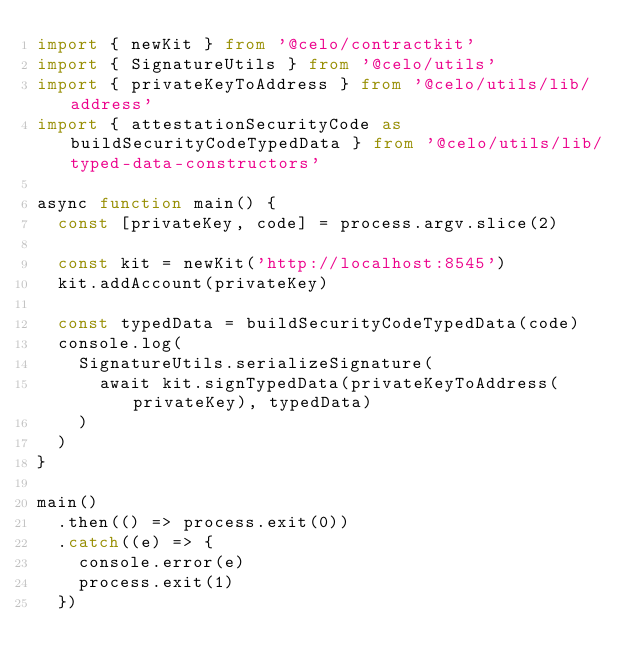Convert code to text. <code><loc_0><loc_0><loc_500><loc_500><_TypeScript_>import { newKit } from '@celo/contractkit'
import { SignatureUtils } from '@celo/utils'
import { privateKeyToAddress } from '@celo/utils/lib/address'
import { attestationSecurityCode as buildSecurityCodeTypedData } from '@celo/utils/lib/typed-data-constructors'

async function main() {
  const [privateKey, code] = process.argv.slice(2)

  const kit = newKit('http://localhost:8545')
  kit.addAccount(privateKey)

  const typedData = buildSecurityCodeTypedData(code)
  console.log(
    SignatureUtils.serializeSignature(
      await kit.signTypedData(privateKeyToAddress(privateKey), typedData)
    )
  )
}

main()
  .then(() => process.exit(0))
  .catch((e) => {
    console.error(e)
    process.exit(1)
  })
</code> 